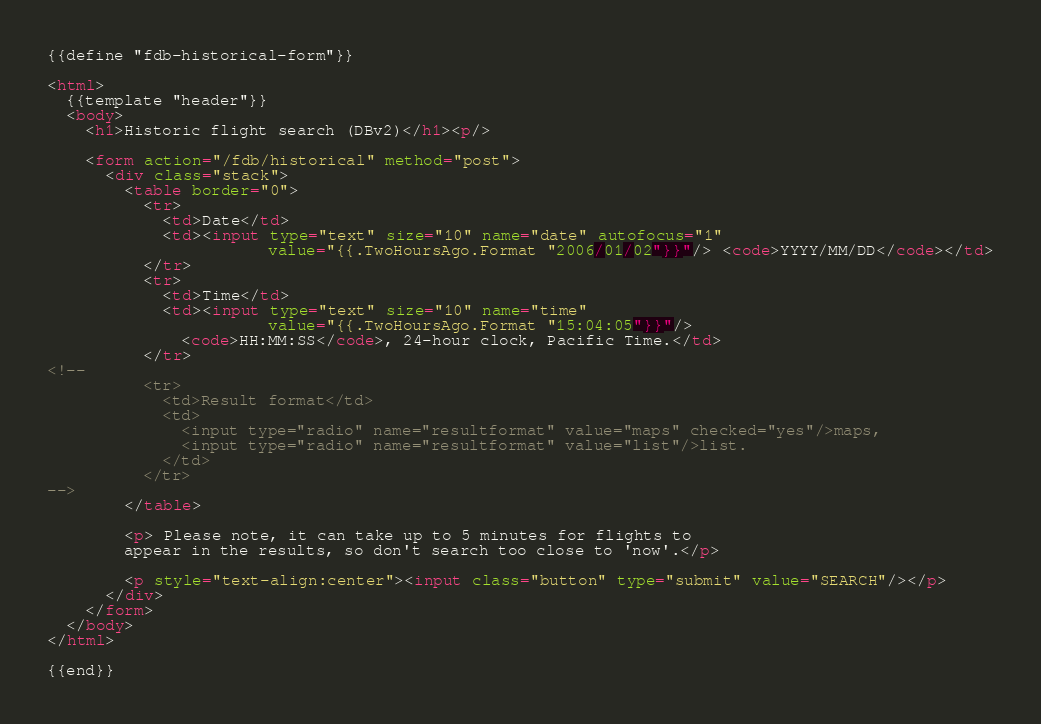Convert code to text. <code><loc_0><loc_0><loc_500><loc_500><_HTML_>{{define "fdb-historical-form"}}

<html>
  {{template "header"}}
  <body>
    <h1>Historic flight search (DBv2)</h1><p/>

    <form action="/fdb/historical" method="post">
      <div class="stack">
        <table border="0">
          <tr>
            <td>Date</td>
            <td><input type="text" size="10" name="date" autofocus="1"
                       value="{{.TwoHoursAgo.Format "2006/01/02"}}"/> <code>YYYY/MM/DD</code></td>
          </tr>
          <tr>
            <td>Time</td>
            <td><input type="text" size="10" name="time"
                       value="{{.TwoHoursAgo.Format "15:04:05"}}"/>
              <code>HH:MM:SS</code>, 24-hour clock, Pacific Time.</td>
          </tr>
<!--
          <tr>
            <td>Result format</td>
            <td>
              <input type="radio" name="resultformat" value="maps" checked="yes"/>maps,
              <input type="radio" name="resultformat" value="list"/>list.
            </td>
          </tr>
-->
        </table>

        <p> Please note, it can take up to 5 minutes for flights to
        appear in the results, so don't search too close to 'now'.</p>
        
        <p style="text-align:center"><input class="button" type="submit" value="SEARCH"/></p>
      </div>
    </form>
  </body>
</html>

{{end}}
</code> 